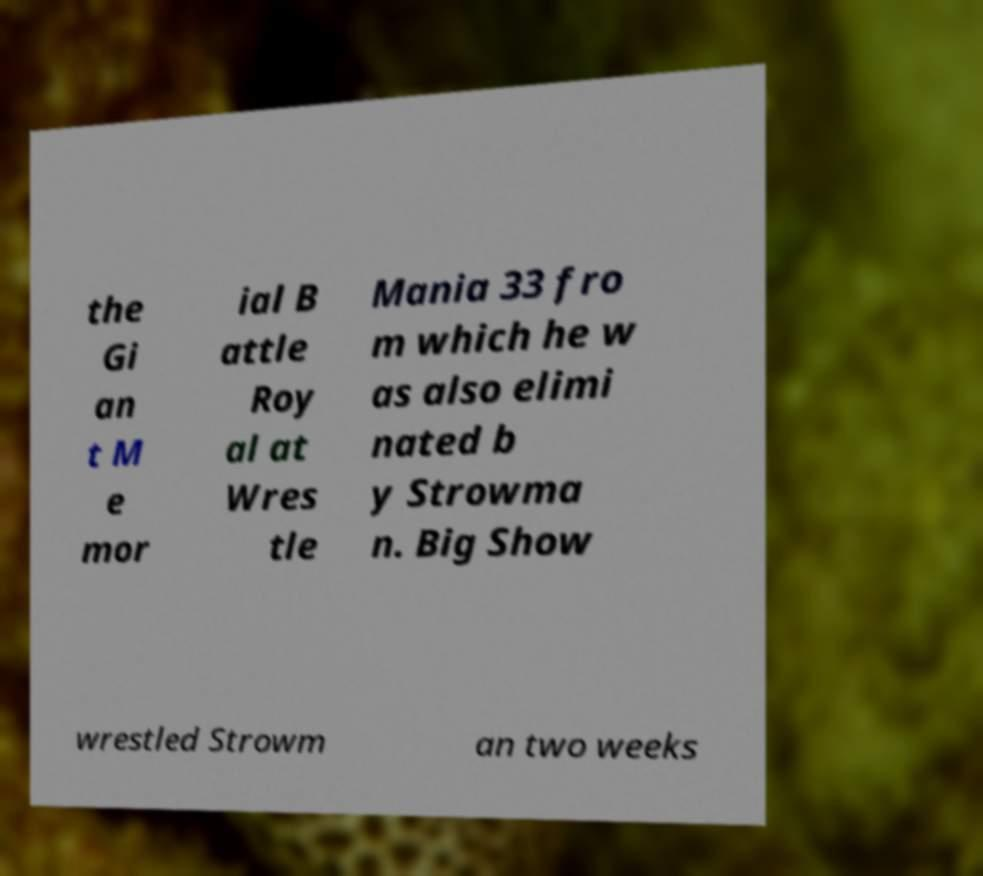There's text embedded in this image that I need extracted. Can you transcribe it verbatim? the Gi an t M e mor ial B attle Roy al at Wres tle Mania 33 fro m which he w as also elimi nated b y Strowma n. Big Show wrestled Strowm an two weeks 